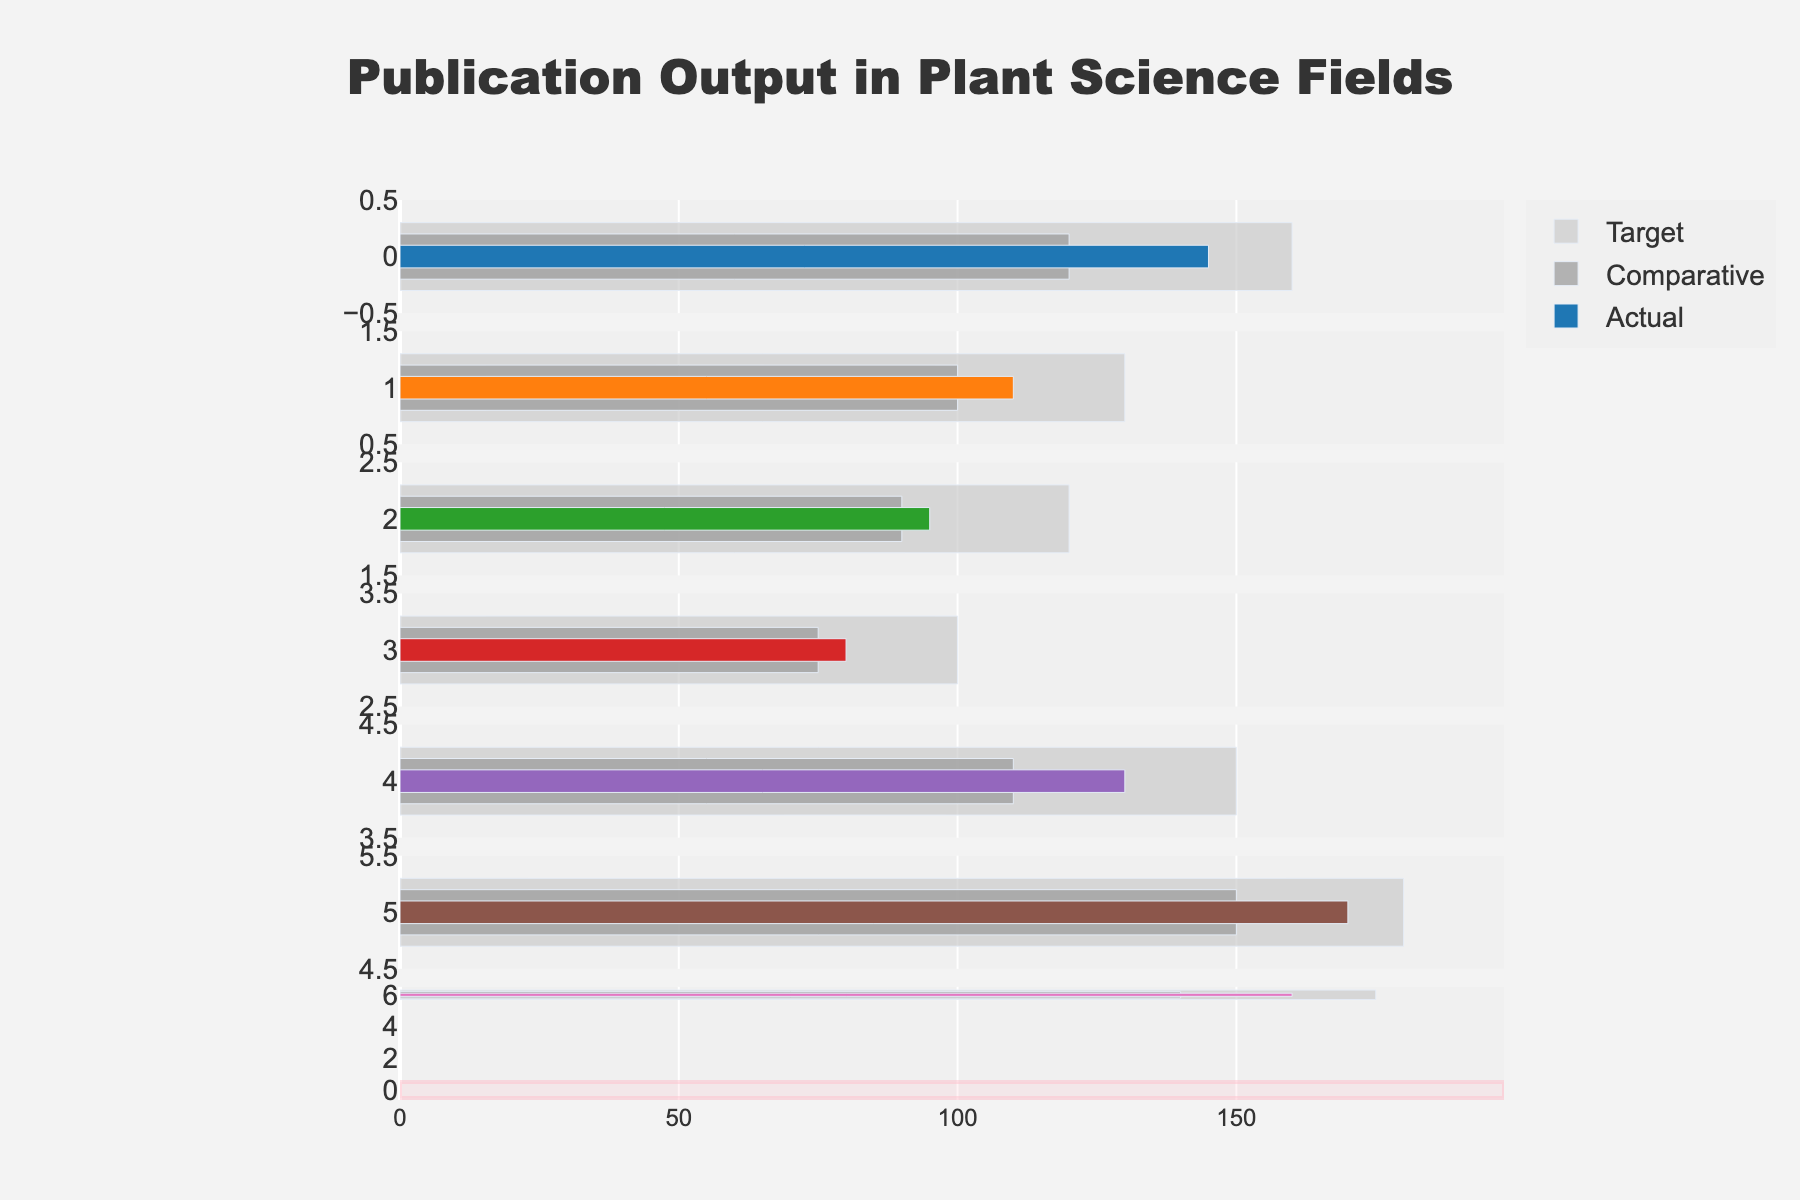What is the title of the figure? The title is usually located at the top of the figure and provides an overall description of what the figure represents. By looking at the top, we can see that the title of the figure is "Publication Output in Plant Science Fields".
Answer: Publication Output in Plant Science Fields Which field has the highest target publication output? To find the highest target publication, we look at the length of the grey bars representing the target values across all fields. The longest grey bar belongs to Plant Breeding.
Answer: Plant Breeding What color represents the actual publication outputs in the figure? The actual publication outputs are depicted by colored bars in the figure. Each field's actual publication output is represented by a different color.
Answer: Different colors (each field has a unique color) How does the actual publication output of Fungal Pathology compare to its target? For Fungal Pathology, compare the length of the colored bar (actual) to the grey bar (target). The actual publication output of Fungal Pathology (145) is less than the target (160).
Answer: Less than target Which field has the smallest actual publication output? Look at the colored bars for each field and find the shortest one. The shortest colored bar, representing the smallest actual publication output, is for Plant Nematology.
Answer: Plant Nematology How much higher is the actual publication output of Plant Breeding compared to Abiotic Stress Research? Subtract the actual publication output of Abiotic Stress Research (130) from that of Plant Breeding (170). The difference is 170 - 130.
Answer: 40 Which field exceeded its comparative publication output by the largest amount? For each field, subtract the comparative output from the actual output and determine the highest value. Fungal Pathology exceeded its comparative output by 145 - 120 = 25. Eraining the explanation for different fields similarly, this is the largest amount.
Answer: Fungal Pathology Are there any fields where the actual publication output exceeds the target? Check if any colored bars (actual) extend beyond the grey bars (target). None of the colored bars exceed their corresponding grey bars, meaning no field has an actual output exceeding the target.
Answer: No In which fields is the actual publication output less than the comparative publication output? Compare the length of the colored bars (actual) to the grey bars (target) for each field: Plant Virology (110 < 100), Plant Bacteriology (95 < 90), Plant Nematology (80 < 75), and Plant Physiology (160 < 140) meet this criterion.
Answer: Plant Virology, Plant Bacteriology, Plant Nematology, Plant Physiology What is the average target publication output across all fields? Sum the target values for all fields (160 + 130 + 120 + 100 + 150 + 180 + 175) and divide it by the number of fields (7). The sum is 1015 and the average is 1015 / 7.
Answer: 145 